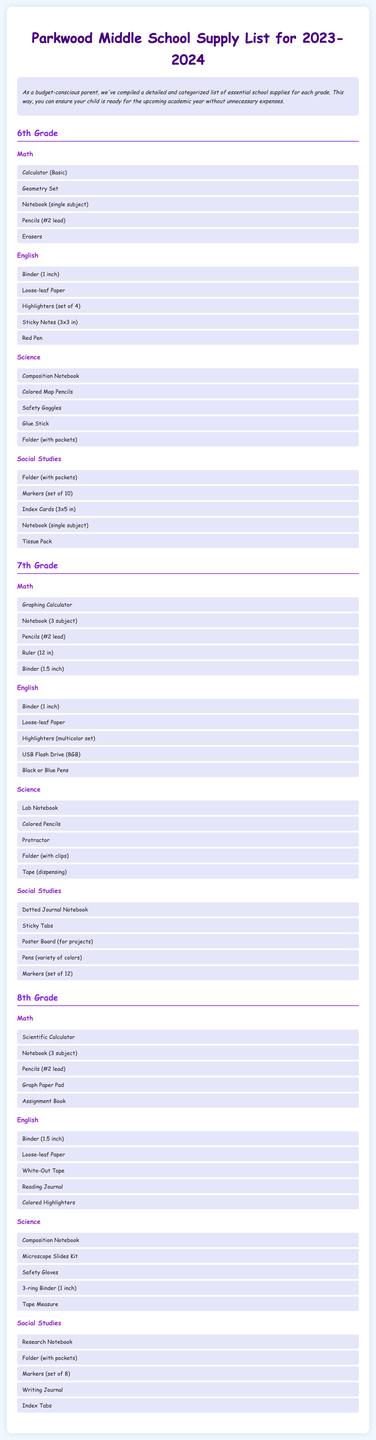What supplies are needed for 6th Grade Math? The document lists specific supplies required for each subject, including Math for 6th Grade.
Answer: Calculator (Basic), Geometry Set, Notebook (single subject), Pencils (#2 lead), Erasers How many subjects are listed for 7th Grade? The document clearly outlines subjects for each grade, enabling identification of how many are included for 7th Grade.
Answer: 4 What type of calculator is required for 8th Grade Math? By reviewing the supplies listed under the Math category for 8th Grade, we can find the specific type of calculator needed.
Answer: Scientific Calculator What writing supplies are mentioned for 6th Grade English? The response looks at the supplies listed under English for 6th Grade, which focus on writing tools.
Answer: Binder (1 inch), Loose-leaf Paper, Highlighters (set of 4), Sticky Notes (3x3 in), Red Pen What is the purpose of the introductory paragraph? The introduction explains the purpose of the document, making it easier for parents to understand the organization and necessity of the list.
Answer: To inform parents about essential school supplies Which grade has a requirement for a USB Flash Drive? By cross-referencing subject listings, the answer reveals which supplies are needed by each grade, focusing on the specific technology needed.
Answer: 7th Grade 